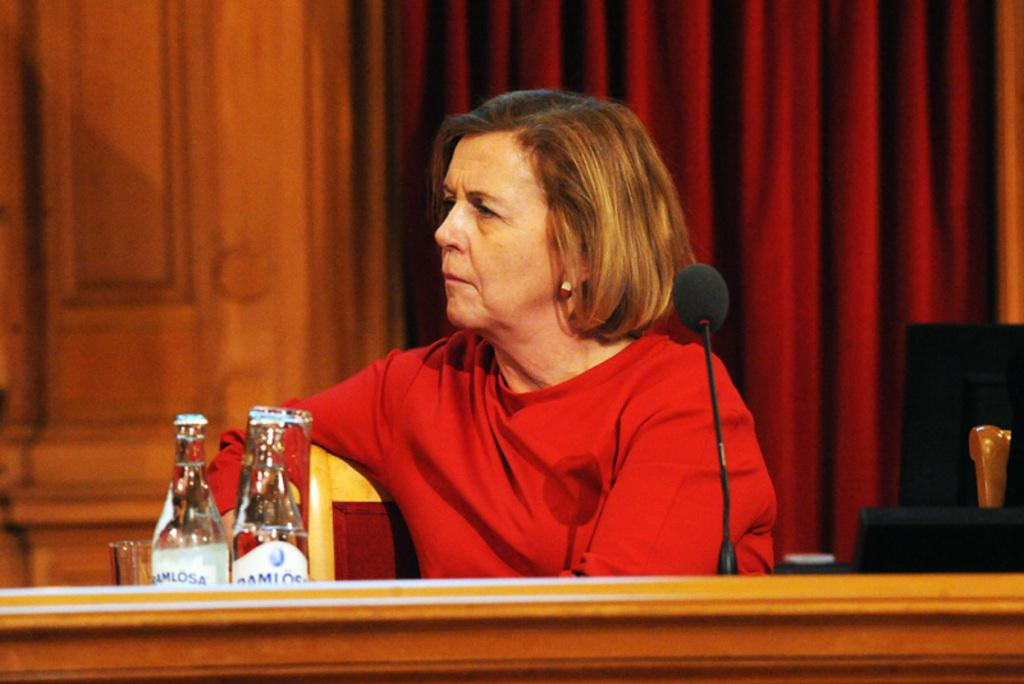What color is the curtain in the image? The curtain in the image is red. What is the woman in the image doing? The woman is sitting on a chair in the image. What piece of furniture is present in the image? There is a table in the image. What object related to sound is on the table? A microphone (mic) is present on the table. What else can be seen on the table besides the microphone? There are bottles on the table. How many dogs are present in the image? There are no dogs present in the image. Is the woman in the image planning a voyage? There is no indication of a voyage or any related activities in the image. 